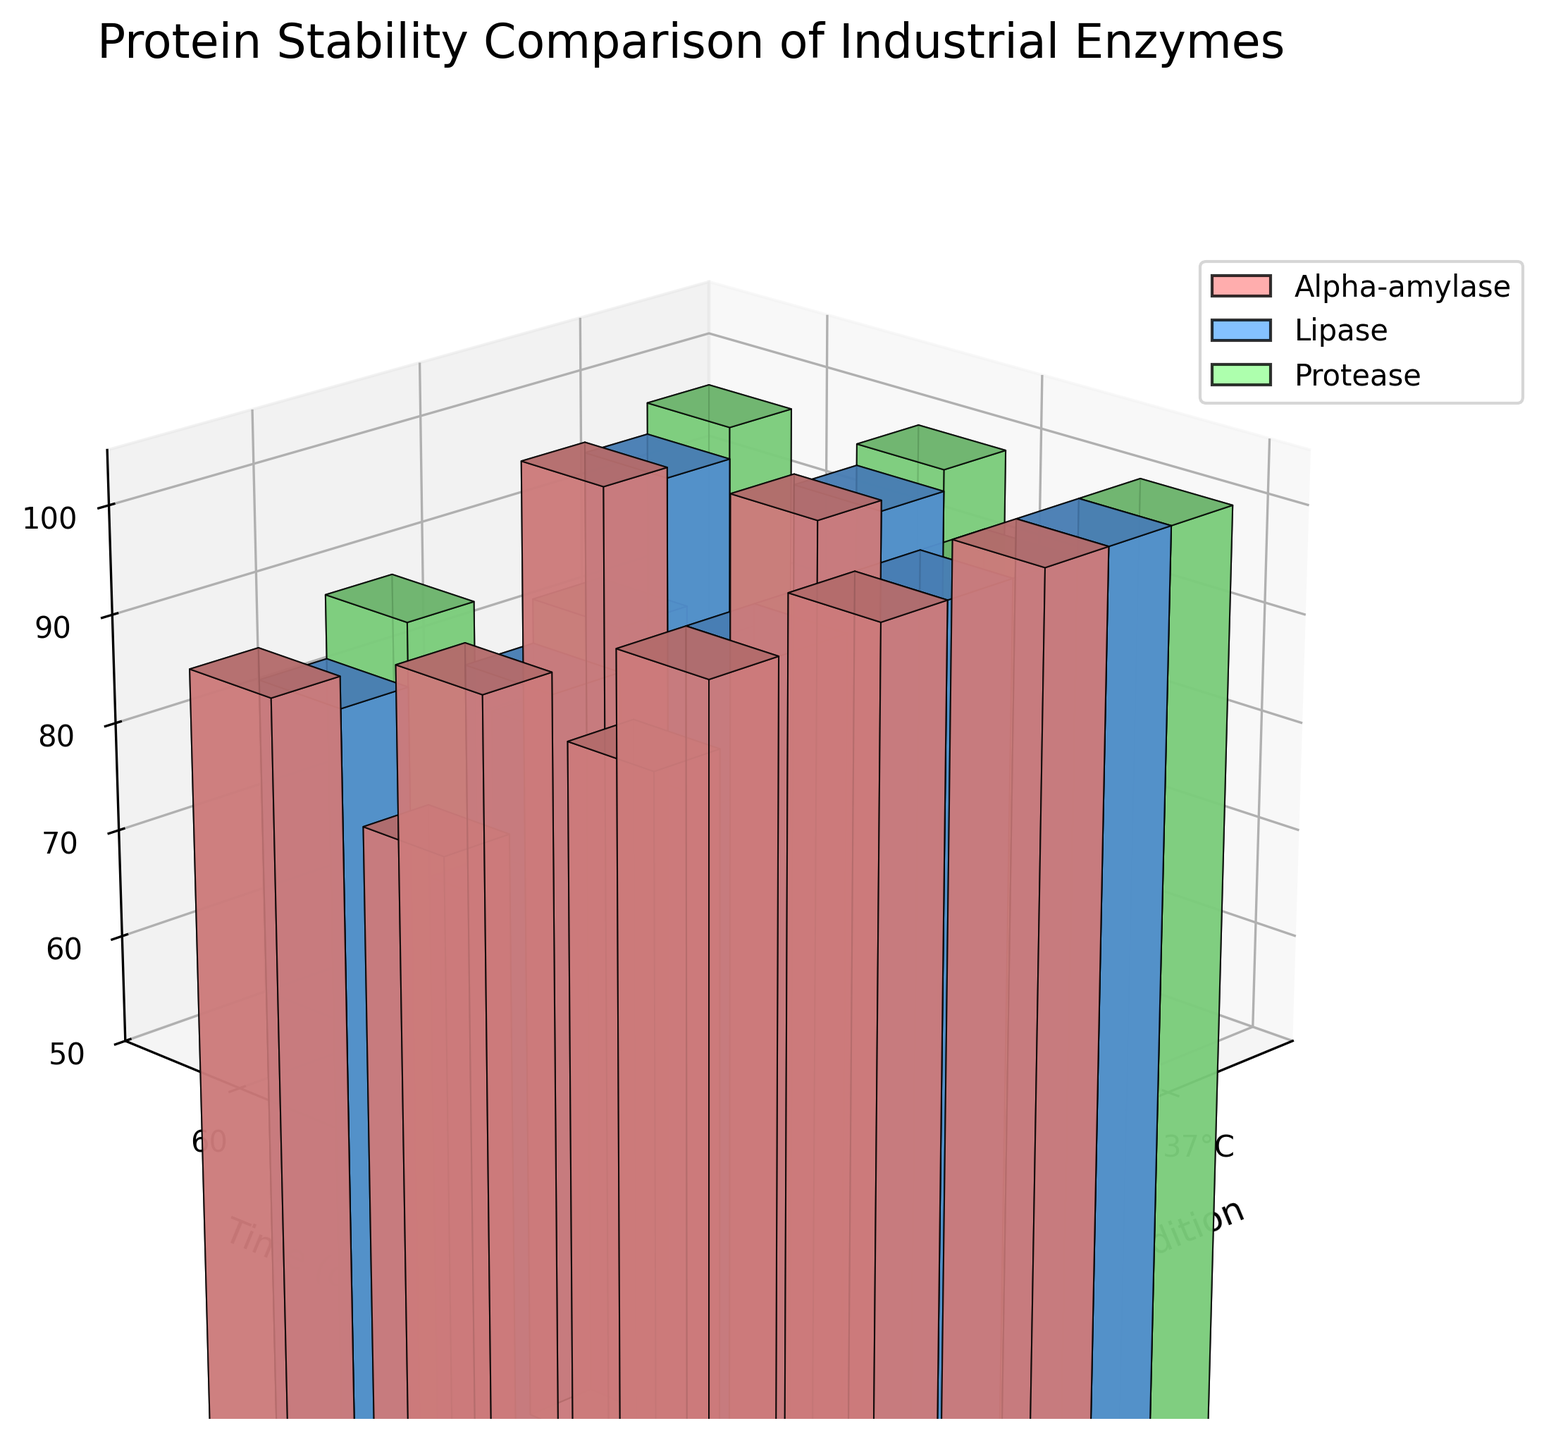What's the title of the figure? The title of the figure is displayed at the top and usually describes the content.
Answer: Protein Stability Comparison of Industrial Enzymes Which storage condition resulted in the highest stability after 60 days for Protease? To determine this, locate the bar representing Protease for each storage condition at 60 days and compare their heights.
Answer: 4°C How does the stability of Alpha-amylase at 37°C and 25°C compare after 30 days? Identify the bars for Alpha-amylase corresponding to 37°C and 25°C at the 30-day mark and compare their heights.
Answer: Lower at 37°C Which enzyme has the most significant decrease in stability over 60 days at 37°C? Observe the bars for each enzyme at 0 and 60 days at 37°C and compare the differences in height.
Answer: Lipase What is the average stability of Lipase at all storage conditions after 30 days? Find the stability values of Lipase at 4°C, 25°C, and 37°C after 30 days, sum them up and divide by three.
Answer: 87.33% Which enzyme shows the least variation in stability across different storage conditions after 60 days? Examine the bars for each enzyme at 60 days across all conditions and note which enzyme's bars are closest in height.
Answer: Protease How does the stability of Alpha-amylase at 25°C change from 0 to 60 days? Identify the bars for Alpha-amylase at 25°C for 0 and 60 days and calculate the difference between their heights.
Answer: Decreases by 15% Which storage condition maintains the highest overall protein stability at 60 days? For each storage condition, find the stable heights of all three enzymes at 60 days and determine the average. The condition with the highest average is the answer.
Answer: 4°C 